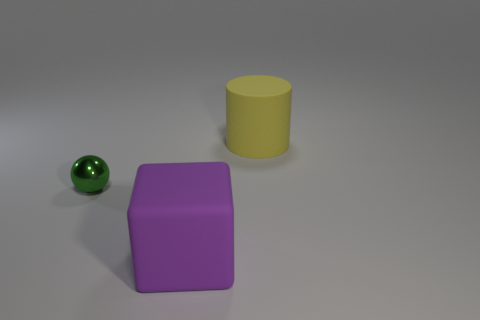Add 2 big purple cubes. How many objects exist? 5 Subtract all balls. How many objects are left? 2 Add 3 purple blocks. How many purple blocks are left? 4 Add 1 matte blocks. How many matte blocks exist? 2 Subtract 1 yellow cylinders. How many objects are left? 2 Subtract all red blocks. Subtract all gray spheres. How many blocks are left? 1 Subtract all small matte cubes. Subtract all purple rubber blocks. How many objects are left? 2 